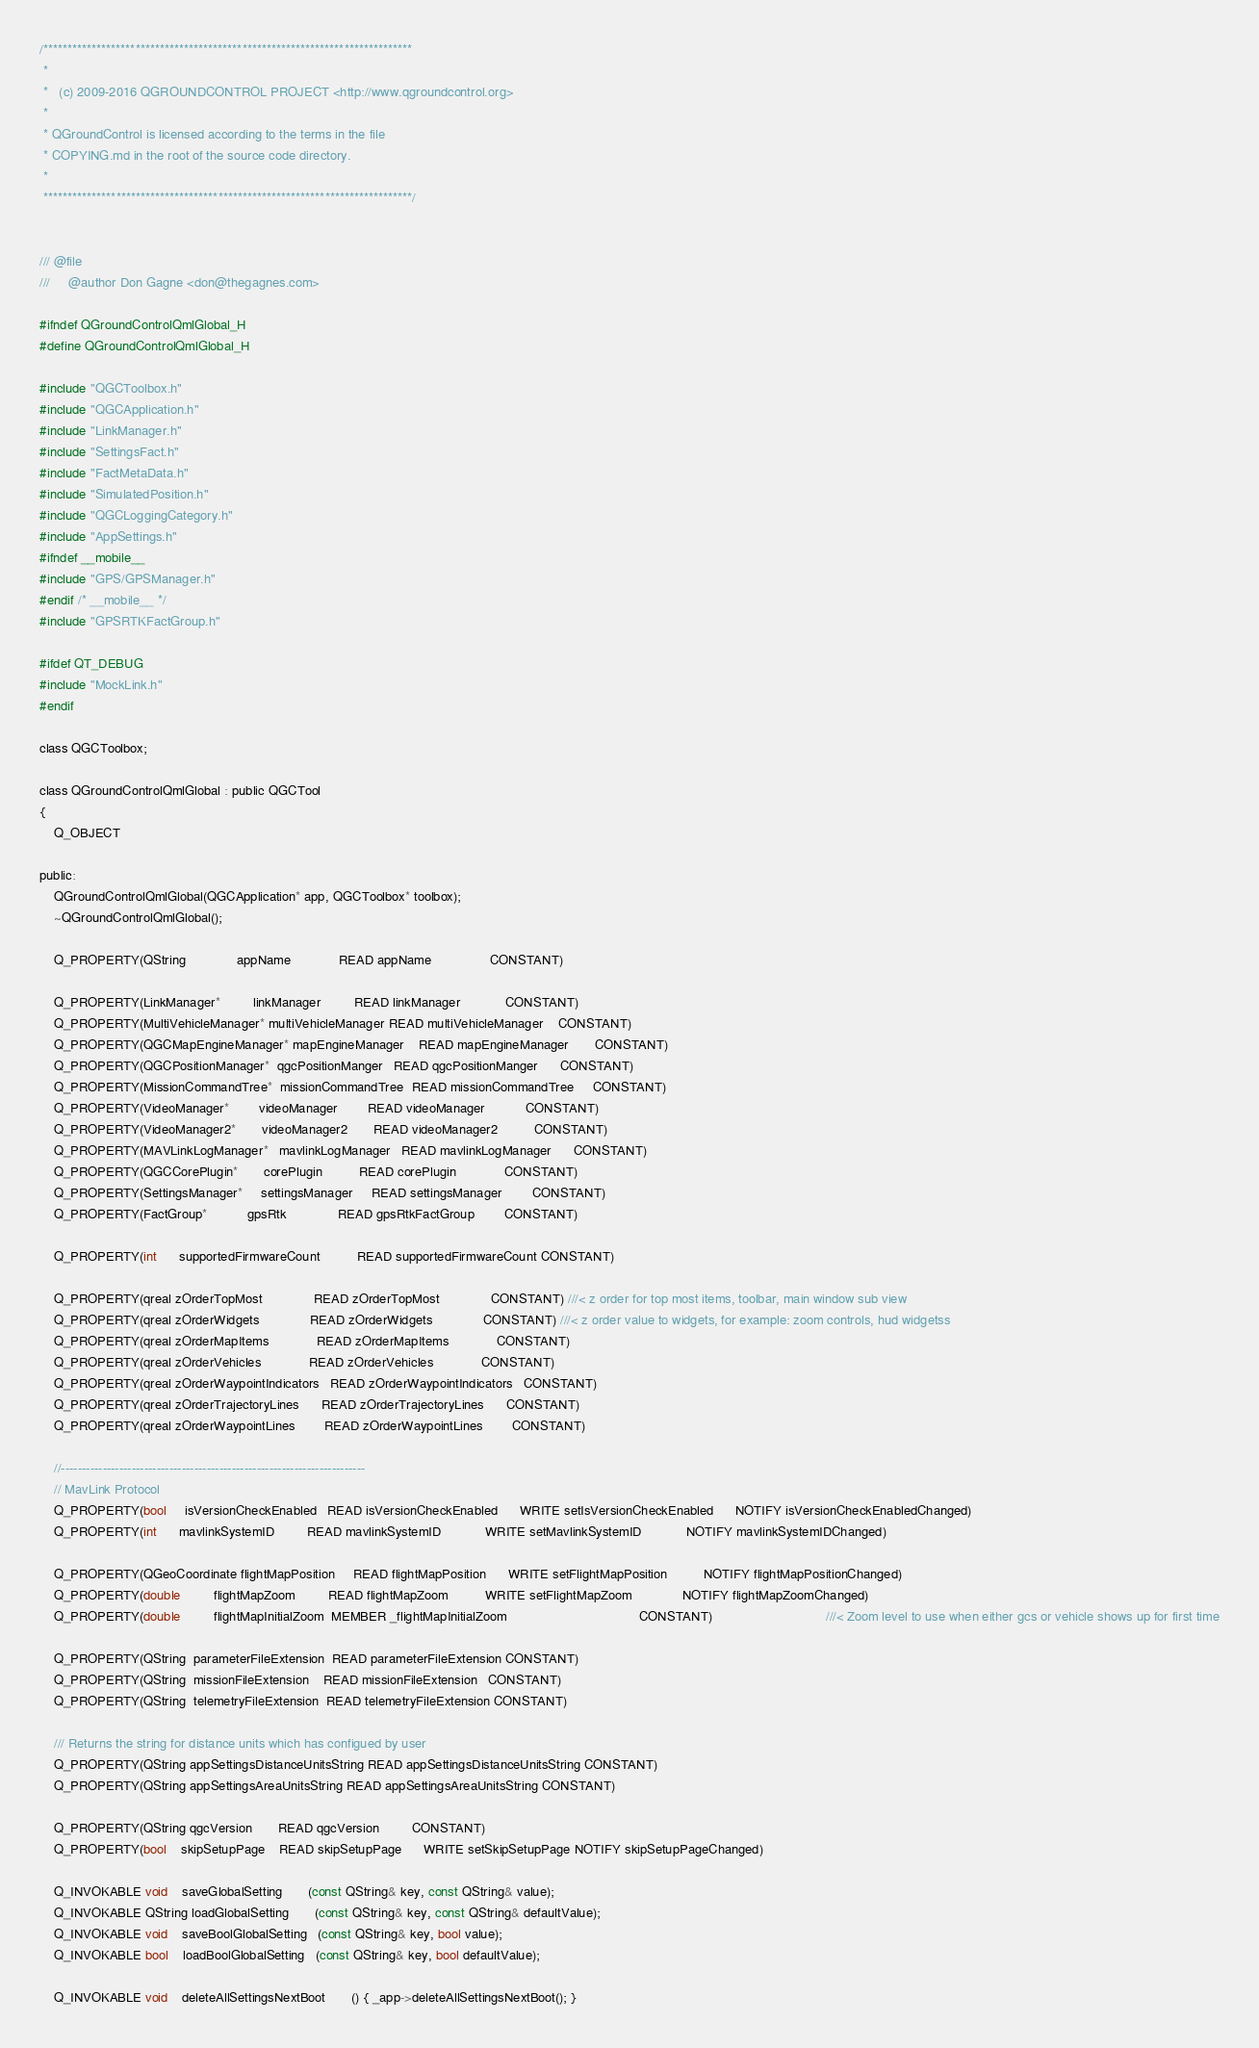Convert code to text. <code><loc_0><loc_0><loc_500><loc_500><_C_>/****************************************************************************
 *
 *   (c) 2009-2016 QGROUNDCONTROL PROJECT <http://www.qgroundcontrol.org>
 *
 * QGroundControl is licensed according to the terms in the file
 * COPYING.md in the root of the source code directory.
 *
 ****************************************************************************/


/// @file
///     @author Don Gagne <don@thegagnes.com>

#ifndef QGroundControlQmlGlobal_H
#define QGroundControlQmlGlobal_H

#include "QGCToolbox.h"
#include "QGCApplication.h"
#include "LinkManager.h"
#include "SettingsFact.h"
#include "FactMetaData.h"
#include "SimulatedPosition.h"
#include "QGCLoggingCategory.h"
#include "AppSettings.h"
#ifndef __mobile__
#include "GPS/GPSManager.h"
#endif /* __mobile__ */
#include "GPSRTKFactGroup.h"

#ifdef QT_DEBUG
#include "MockLink.h"
#endif

class QGCToolbox;

class QGroundControlQmlGlobal : public QGCTool
{
    Q_OBJECT

public:
    QGroundControlQmlGlobal(QGCApplication* app, QGCToolbox* toolbox);
    ~QGroundControlQmlGlobal();

    Q_PROPERTY(QString              appName             READ appName                CONSTANT)

    Q_PROPERTY(LinkManager*         linkManager         READ linkManager            CONSTANT)
    Q_PROPERTY(MultiVehicleManager* multiVehicleManager READ multiVehicleManager    CONSTANT)
    Q_PROPERTY(QGCMapEngineManager* mapEngineManager    READ mapEngineManager       CONSTANT)
    Q_PROPERTY(QGCPositionManager*  qgcPositionManger   READ qgcPositionManger      CONSTANT)
    Q_PROPERTY(MissionCommandTree*  missionCommandTree  READ missionCommandTree     CONSTANT)
    Q_PROPERTY(VideoManager*        videoManager        READ videoManager           CONSTANT)
    Q_PROPERTY(VideoManager2*       videoManager2       READ videoManager2          CONSTANT)
    Q_PROPERTY(MAVLinkLogManager*   mavlinkLogManager   READ mavlinkLogManager      CONSTANT)
    Q_PROPERTY(QGCCorePlugin*       corePlugin          READ corePlugin             CONSTANT)
    Q_PROPERTY(SettingsManager*     settingsManager     READ settingsManager        CONSTANT)
    Q_PROPERTY(FactGroup*           gpsRtk              READ gpsRtkFactGroup        CONSTANT)

    Q_PROPERTY(int      supportedFirmwareCount          READ supportedFirmwareCount CONSTANT)

    Q_PROPERTY(qreal zOrderTopMost              READ zOrderTopMost              CONSTANT) ///< z order for top most items, toolbar, main window sub view
    Q_PROPERTY(qreal zOrderWidgets              READ zOrderWidgets              CONSTANT) ///< z order value to widgets, for example: zoom controls, hud widgetss
    Q_PROPERTY(qreal zOrderMapItems             READ zOrderMapItems             CONSTANT)
    Q_PROPERTY(qreal zOrderVehicles             READ zOrderVehicles             CONSTANT)
    Q_PROPERTY(qreal zOrderWaypointIndicators   READ zOrderWaypointIndicators   CONSTANT)
    Q_PROPERTY(qreal zOrderTrajectoryLines      READ zOrderTrajectoryLines      CONSTANT)
    Q_PROPERTY(qreal zOrderWaypointLines        READ zOrderWaypointLines        CONSTANT)

    //-------------------------------------------------------------------------
    // MavLink Protocol
    Q_PROPERTY(bool     isVersionCheckEnabled   READ isVersionCheckEnabled      WRITE setIsVersionCheckEnabled      NOTIFY isVersionCheckEnabledChanged)
    Q_PROPERTY(int      mavlinkSystemID         READ mavlinkSystemID            WRITE setMavlinkSystemID            NOTIFY mavlinkSystemIDChanged)

    Q_PROPERTY(QGeoCoordinate flightMapPosition     READ flightMapPosition      WRITE setFlightMapPosition          NOTIFY flightMapPositionChanged)
    Q_PROPERTY(double         flightMapZoom         READ flightMapZoom          WRITE setFlightMapZoom              NOTIFY flightMapZoomChanged)
    Q_PROPERTY(double         flightMapInitialZoom  MEMBER _flightMapInitialZoom                                    CONSTANT)                               ///< Zoom level to use when either gcs or vehicle shows up for first time

    Q_PROPERTY(QString  parameterFileExtension  READ parameterFileExtension CONSTANT)
    Q_PROPERTY(QString  missionFileExtension    READ missionFileExtension   CONSTANT)
    Q_PROPERTY(QString  telemetryFileExtension  READ telemetryFileExtension CONSTANT)

    /// Returns the string for distance units which has configued by user
    Q_PROPERTY(QString appSettingsDistanceUnitsString READ appSettingsDistanceUnitsString CONSTANT)
    Q_PROPERTY(QString appSettingsAreaUnitsString READ appSettingsAreaUnitsString CONSTANT)

    Q_PROPERTY(QString qgcVersion       READ qgcVersion         CONSTANT)
    Q_PROPERTY(bool    skipSetupPage    READ skipSetupPage      WRITE setSkipSetupPage NOTIFY skipSetupPageChanged)

    Q_INVOKABLE void    saveGlobalSetting       (const QString& key, const QString& value);
    Q_INVOKABLE QString loadGlobalSetting       (const QString& key, const QString& defaultValue);
    Q_INVOKABLE void    saveBoolGlobalSetting   (const QString& key, bool value);
    Q_INVOKABLE bool    loadBoolGlobalSetting   (const QString& key, bool defaultValue);

    Q_INVOKABLE void    deleteAllSettingsNextBoot       () { _app->deleteAllSettingsNextBoot(); }</code> 